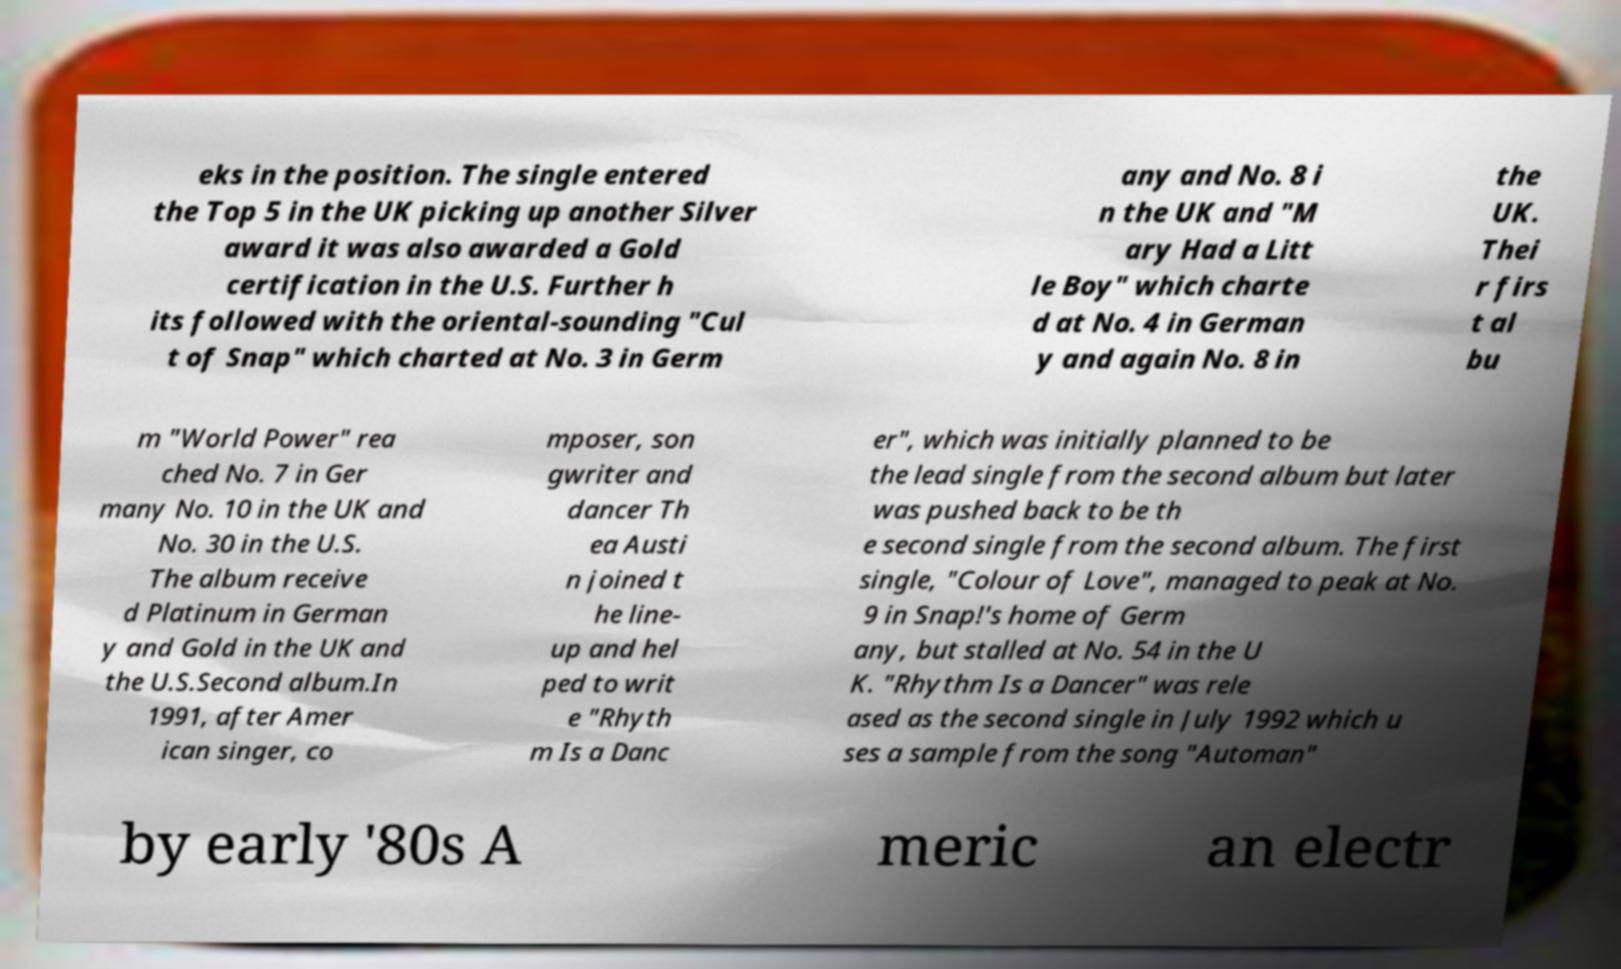Could you assist in decoding the text presented in this image and type it out clearly? eks in the position. The single entered the Top 5 in the UK picking up another Silver award it was also awarded a Gold certification in the U.S. Further h its followed with the oriental-sounding "Cul t of Snap" which charted at No. 3 in Germ any and No. 8 i n the UK and "M ary Had a Litt le Boy" which charte d at No. 4 in German y and again No. 8 in the UK. Thei r firs t al bu m "World Power" rea ched No. 7 in Ger many No. 10 in the UK and No. 30 in the U.S. The album receive d Platinum in German y and Gold in the UK and the U.S.Second album.In 1991, after Amer ican singer, co mposer, son gwriter and dancer Th ea Austi n joined t he line- up and hel ped to writ e "Rhyth m Is a Danc er", which was initially planned to be the lead single from the second album but later was pushed back to be th e second single from the second album. The first single, "Colour of Love", managed to peak at No. 9 in Snap!'s home of Germ any, but stalled at No. 54 in the U K. "Rhythm Is a Dancer" was rele ased as the second single in July 1992 which u ses a sample from the song "Automan" by early '80s A meric an electr 